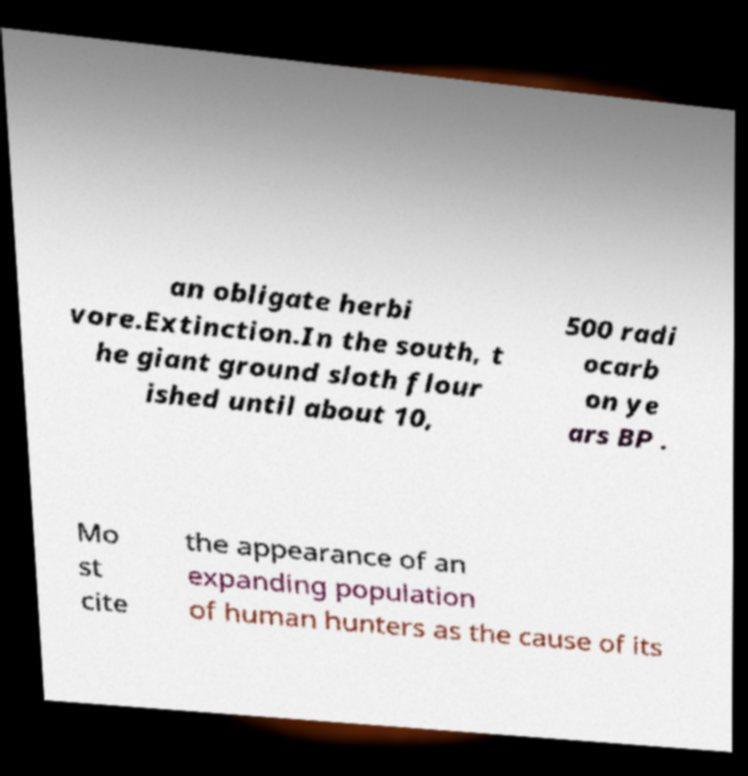Can you read and provide the text displayed in the image?This photo seems to have some interesting text. Can you extract and type it out for me? an obligate herbi vore.Extinction.In the south, t he giant ground sloth flour ished until about 10, 500 radi ocarb on ye ars BP . Mo st cite the appearance of an expanding population of human hunters as the cause of its 